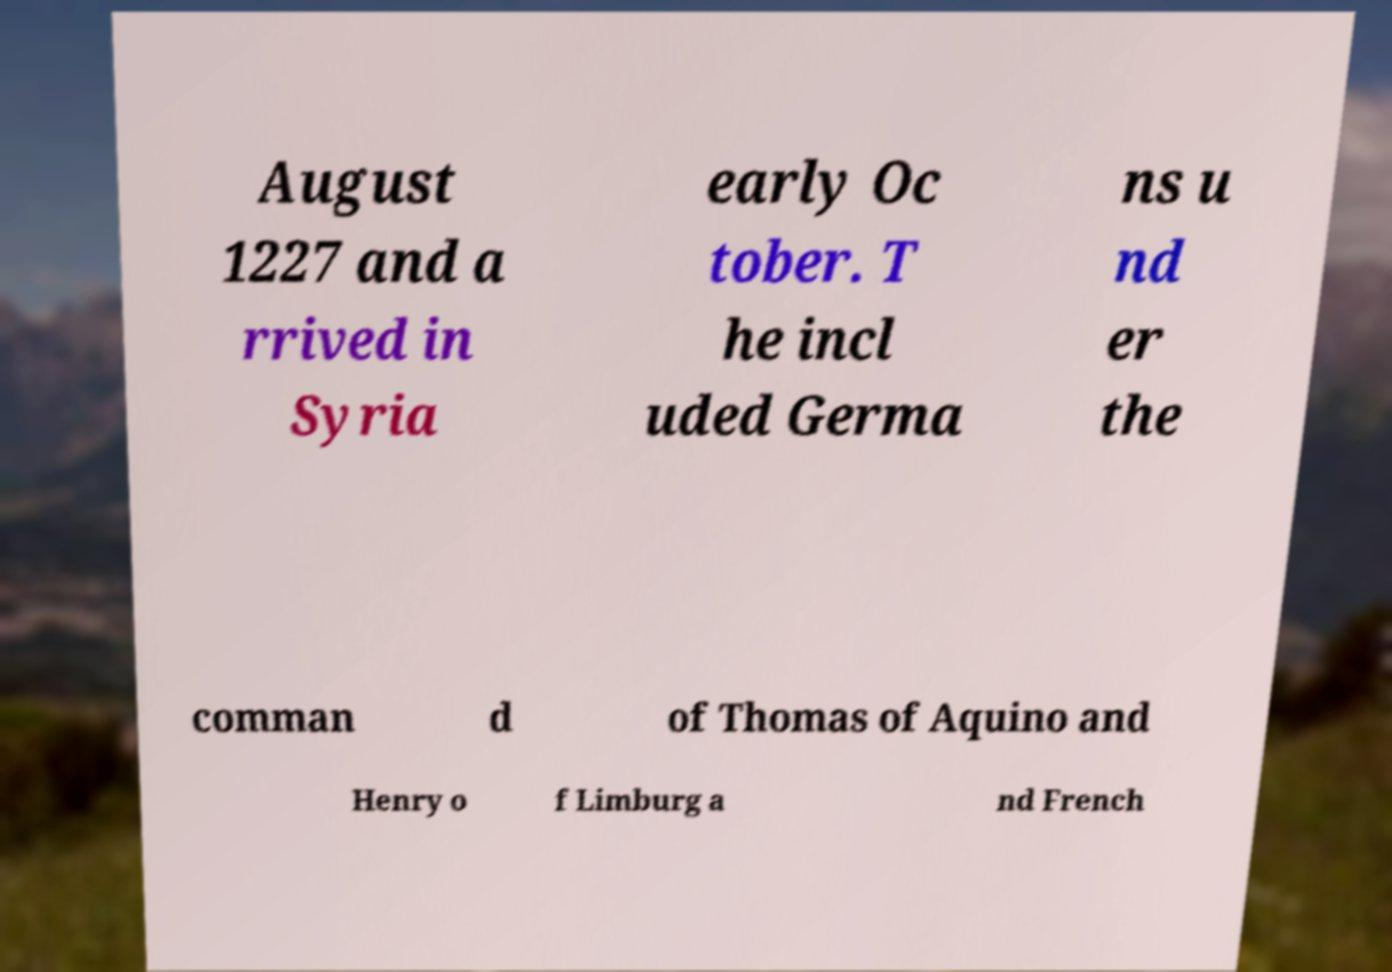Can you read and provide the text displayed in the image?This photo seems to have some interesting text. Can you extract and type it out for me? August 1227 and a rrived in Syria early Oc tober. T he incl uded Germa ns u nd er the comman d of Thomas of Aquino and Henry o f Limburg a nd French 